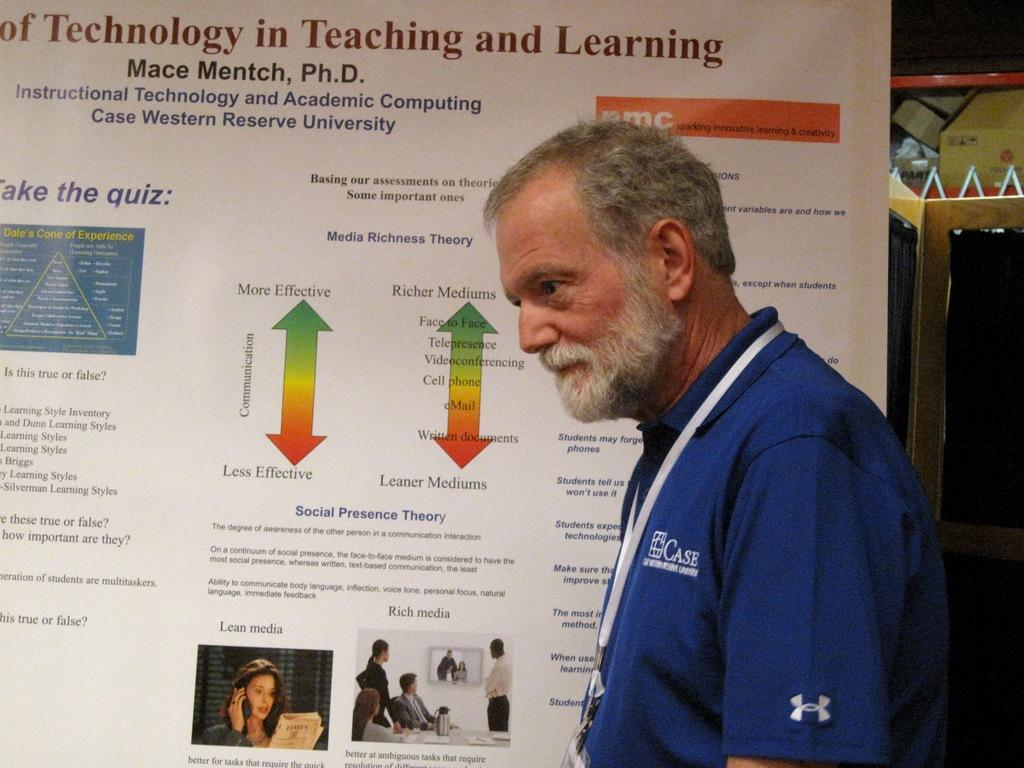<image>
Offer a succinct explanation of the picture presented. Man teaching on a visual, saying: Mace Mentch Ph.D. Instructional Technology and Academic Computing Case Western Reserve University. 